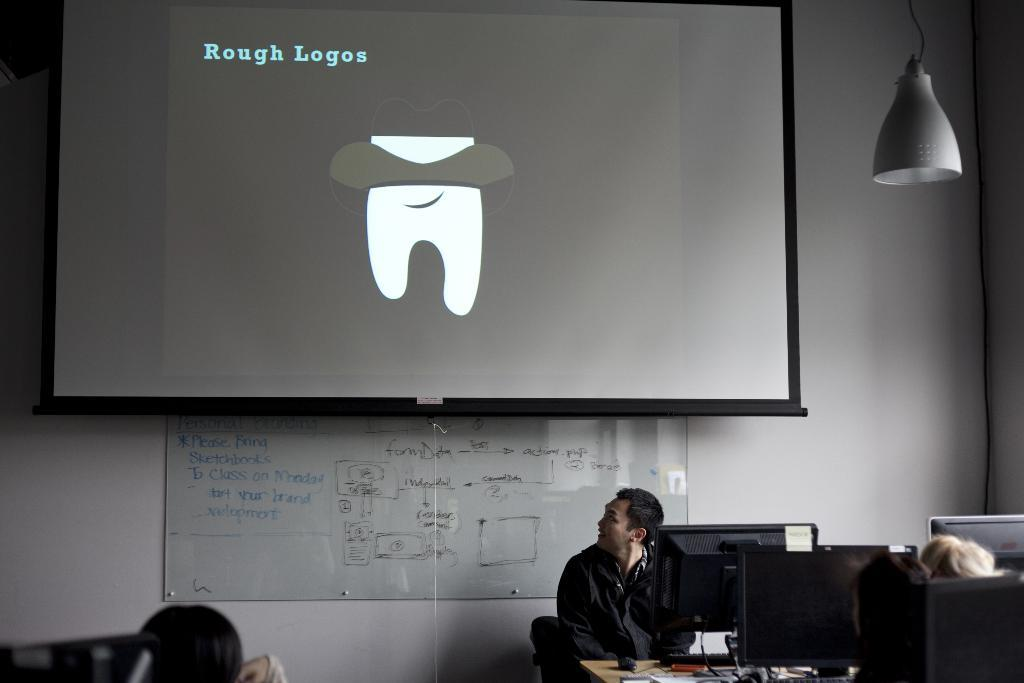What are the people in the image doing? The people are sitting in the image. Where are the people sitting? The people are sitting in front of tables. What is on the tables in the image? There are screens on the tables. What other large objects can be seen in the image? There is a projector screen and a whiteboard in the image. What type of jam is being spread on the nut in the image? There is no jam or nut present in the image. 